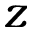<formula> <loc_0><loc_0><loc_500><loc_500>z</formula> 